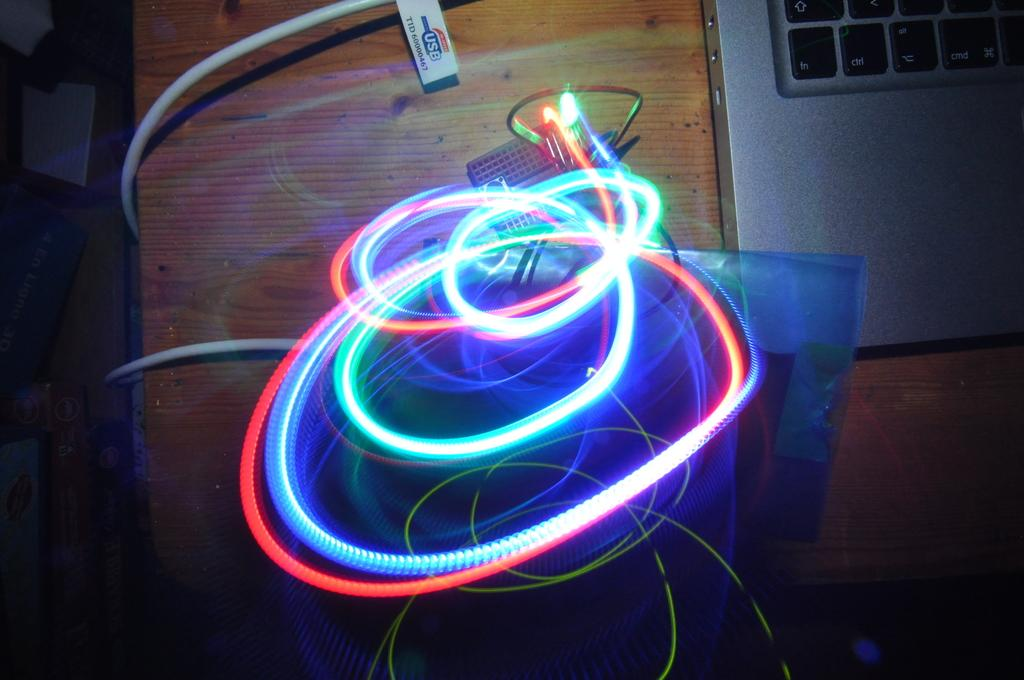What is located in the center of the image? In the center of the image, there are lights, cables, and a black color object that resembles a breadboard. What electronic device can be seen in the image? A laptop is visible in the image. What type of furniture is present in the image? There is a table in the image. Can you describe any other objects in the image? There are other unspecified objects in the image. Is there a tub filled with water in the image? No, there is no tub filled with water in the image. Can you see a rat running across the table in the image? No, there is no rat present in the image. 